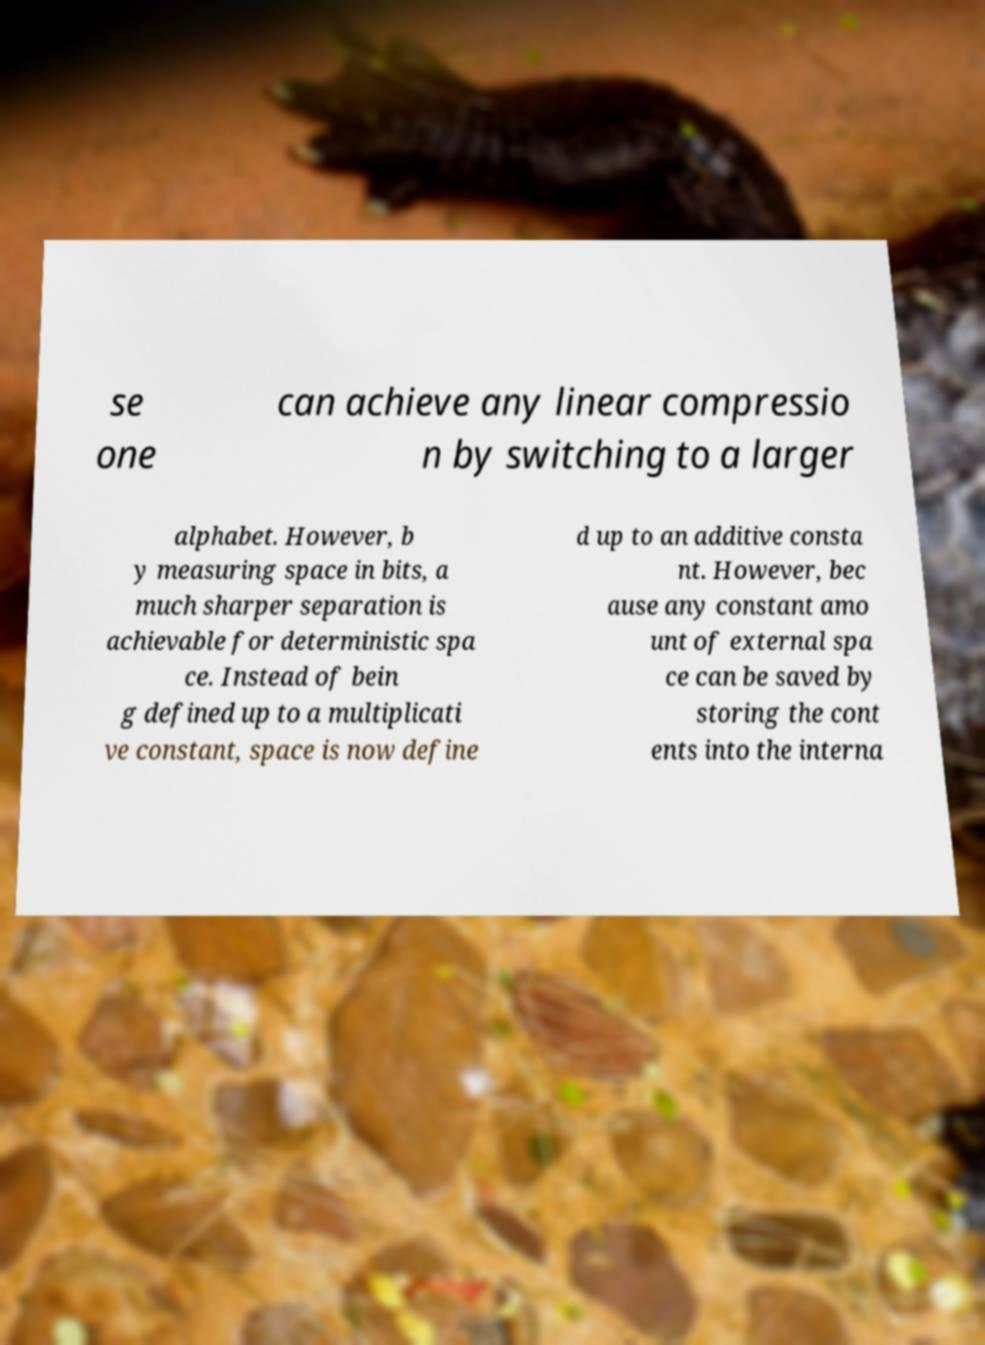I need the written content from this picture converted into text. Can you do that? se one can achieve any linear compressio n by switching to a larger alphabet. However, b y measuring space in bits, a much sharper separation is achievable for deterministic spa ce. Instead of bein g defined up to a multiplicati ve constant, space is now define d up to an additive consta nt. However, bec ause any constant amo unt of external spa ce can be saved by storing the cont ents into the interna 